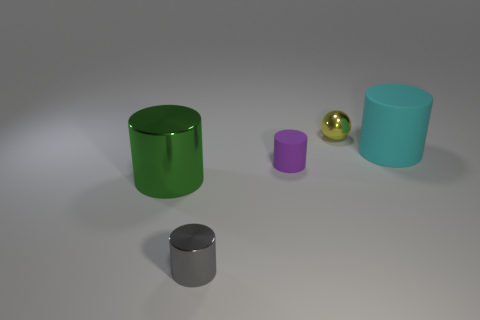What material is the other big thing that is the same shape as the big cyan matte thing?
Keep it short and to the point. Metal. Is there any other thing that has the same material as the cyan cylinder?
Offer a very short reply. Yes. Is the color of the small ball the same as the large rubber thing?
Your answer should be compact. No. What is the shape of the gray thing that is the same material as the sphere?
Offer a terse response. Cylinder. What number of tiny matte things are the same shape as the big metallic object?
Keep it short and to the point. 1. There is a rubber object that is in front of the big cylinder right of the small shiny cylinder; what shape is it?
Your response must be concise. Cylinder. There is a rubber cylinder that is left of the cyan matte object; does it have the same size as the yellow metal object?
Make the answer very short. Yes. There is a metallic thing that is to the left of the purple object and on the right side of the green cylinder; what size is it?
Your response must be concise. Small. How many shiny things are the same size as the cyan matte cylinder?
Make the answer very short. 1. There is a rubber cylinder that is in front of the big cyan cylinder; how many small yellow metallic things are in front of it?
Provide a succinct answer. 0. 